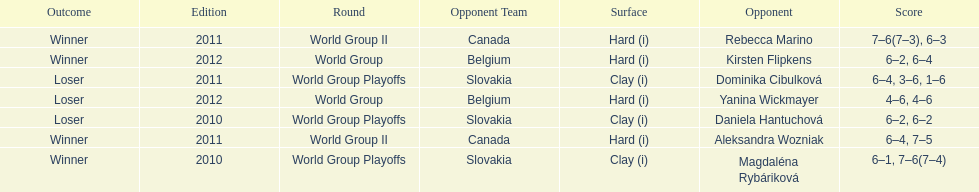Was the game versus canada later than the game versus belgium? No. 